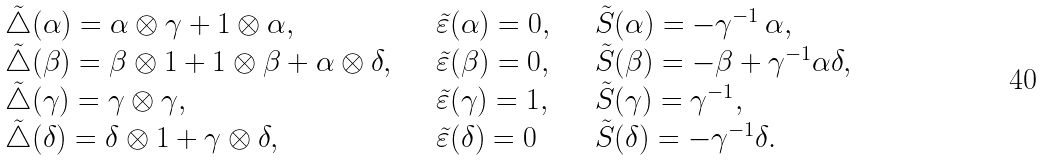<formula> <loc_0><loc_0><loc_500><loc_500>\begin{array} { l l l } { \tilde { \bigtriangleup } } ( \alpha ) = \alpha \otimes \gamma + 1 \otimes \alpha , & \quad { \tilde { \varepsilon } } ( \alpha ) = 0 , & \quad { \tilde { S } } ( \alpha ) = - \gamma ^ { - 1 } \, \alpha , \\ { \tilde { \bigtriangleup } } ( \beta ) = \beta \otimes 1 + 1 \otimes \beta + \alpha \otimes \delta , & \quad { \tilde { \varepsilon } } ( \beta ) = 0 , & \quad { \tilde { S } } ( \beta ) = - \beta + \gamma ^ { - 1 } \alpha \delta , \\ { \tilde { \bigtriangleup } } ( \gamma ) = \gamma \otimes \gamma , & \quad { \tilde { \varepsilon } } ( \gamma ) = 1 , & \quad { \tilde { S } } ( \gamma ) = \gamma ^ { - 1 } , \\ { \tilde { \bigtriangleup } } ( \delta ) = \delta \otimes 1 + \gamma \otimes \delta , & \quad { \tilde { \varepsilon } } ( \delta ) = 0 & \quad { \tilde { S } } ( \delta ) = - \gamma ^ { - 1 } \delta . \end{array}</formula> 